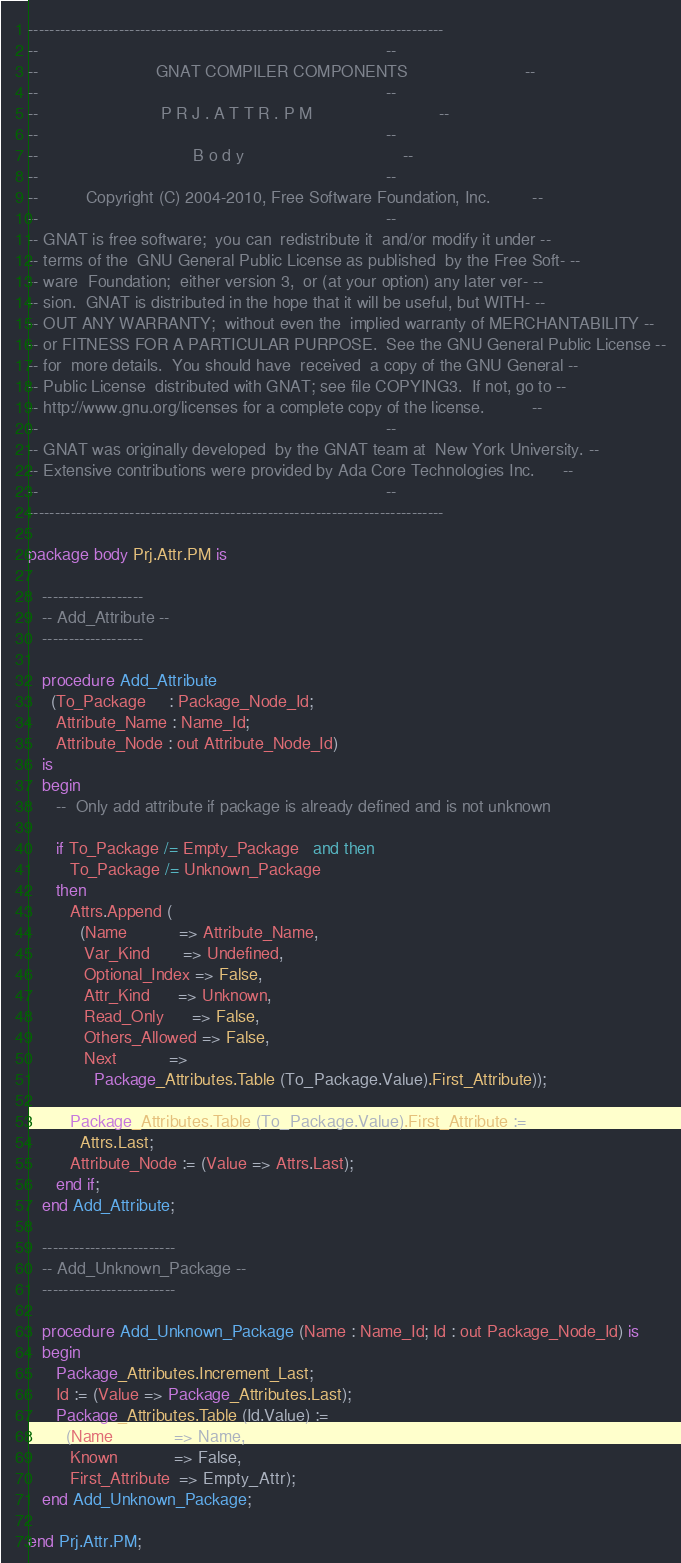Convert code to text. <code><loc_0><loc_0><loc_500><loc_500><_Ada_>------------------------------------------------------------------------------
--                                                                          --
--                         GNAT COMPILER COMPONENTS                         --
--                                                                          --
--                          P R J . A T T R . P M                           --
--                                                                          --
--                                 B o d y                                  --
--                                                                          --
--          Copyright (C) 2004-2010, Free Software Foundation, Inc.         --
--                                                                          --
-- GNAT is free software;  you can  redistribute it  and/or modify it under --
-- terms of the  GNU General Public License as published  by the Free Soft- --
-- ware  Foundation;  either version 3,  or (at your option) any later ver- --
-- sion.  GNAT is distributed in the hope that it will be useful, but WITH- --
-- OUT ANY WARRANTY;  without even the  implied warranty of MERCHANTABILITY --
-- or FITNESS FOR A PARTICULAR PURPOSE.  See the GNU General Public License --
-- for  more details.  You should have  received  a copy of the GNU General --
-- Public License  distributed with GNAT; see file COPYING3.  If not, go to --
-- http://www.gnu.org/licenses for a complete copy of the license.          --
--                                                                          --
-- GNAT was originally developed  by the GNAT team at  New York University. --
-- Extensive contributions were provided by Ada Core Technologies Inc.      --
--                                                                          --
------------------------------------------------------------------------------

package body Prj.Attr.PM is

   -------------------
   -- Add_Attribute --
   -------------------

   procedure Add_Attribute
     (To_Package     : Package_Node_Id;
      Attribute_Name : Name_Id;
      Attribute_Node : out Attribute_Node_Id)
   is
   begin
      --  Only add attribute if package is already defined and is not unknown

      if To_Package /= Empty_Package   and then
         To_Package /= Unknown_Package
      then
         Attrs.Append (
           (Name           => Attribute_Name,
            Var_Kind       => Undefined,
            Optional_Index => False,
            Attr_Kind      => Unknown,
            Read_Only      => False,
            Others_Allowed => False,
            Next           =>
              Package_Attributes.Table (To_Package.Value).First_Attribute));

         Package_Attributes.Table (To_Package.Value).First_Attribute :=
           Attrs.Last;
         Attribute_Node := (Value => Attrs.Last);
      end if;
   end Add_Attribute;

   -------------------------
   -- Add_Unknown_Package --
   -------------------------

   procedure Add_Unknown_Package (Name : Name_Id; Id : out Package_Node_Id) is
   begin
      Package_Attributes.Increment_Last;
      Id := (Value => Package_Attributes.Last);
      Package_Attributes.Table (Id.Value) :=
        (Name             => Name,
         Known            => False,
         First_Attribute  => Empty_Attr);
   end Add_Unknown_Package;

end Prj.Attr.PM;
</code> 